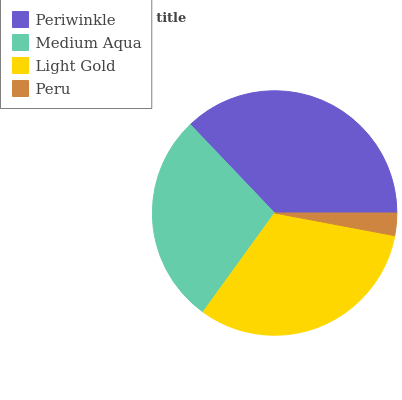Is Peru the minimum?
Answer yes or no. Yes. Is Periwinkle the maximum?
Answer yes or no. Yes. Is Medium Aqua the minimum?
Answer yes or no. No. Is Medium Aqua the maximum?
Answer yes or no. No. Is Periwinkle greater than Medium Aqua?
Answer yes or no. Yes. Is Medium Aqua less than Periwinkle?
Answer yes or no. Yes. Is Medium Aqua greater than Periwinkle?
Answer yes or no. No. Is Periwinkle less than Medium Aqua?
Answer yes or no. No. Is Light Gold the high median?
Answer yes or no. Yes. Is Medium Aqua the low median?
Answer yes or no. Yes. Is Peru the high median?
Answer yes or no. No. Is Periwinkle the low median?
Answer yes or no. No. 